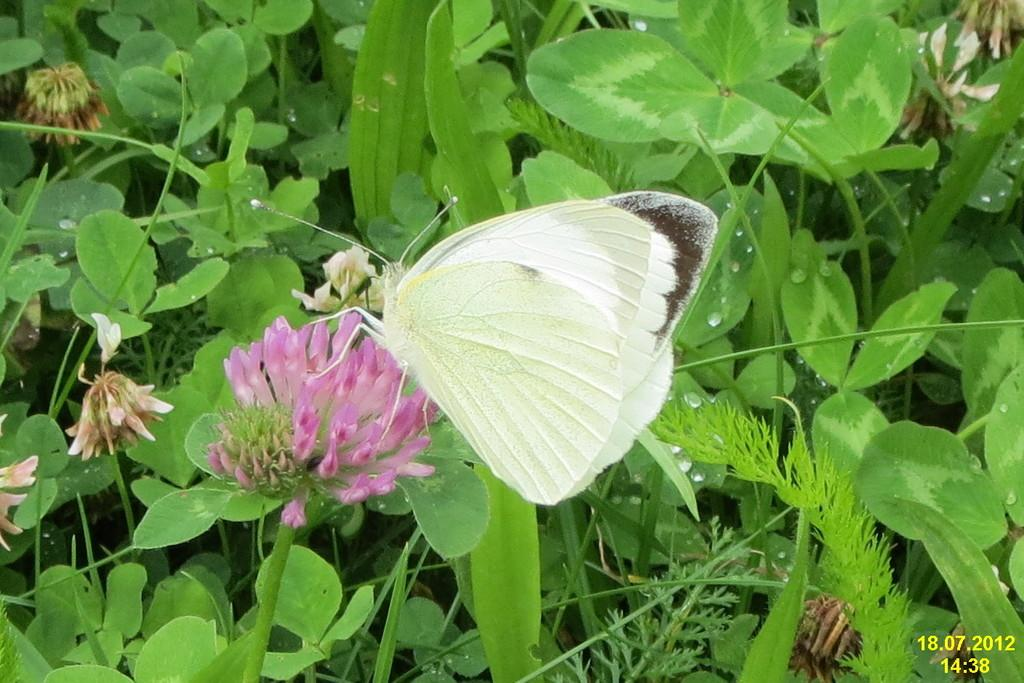What is the main subject of the image? There is a butterfly in the image. What is the butterfly doing in the image? The butterfly is standing on a flower. Can you describe the flower the butterfly is standing on? The flower is on a stem of a plant. What can be seen in the background of the image? There is a group of plants in the background of the image. How many sisters are present in the image? There are no sisters present in the image; it features a butterfly standing on a flower. What type of rake is being used to maintain the wilderness in the image? There is no rake or wilderness present in the image; it features a butterfly standing on a flower and a group of plants in the background. 